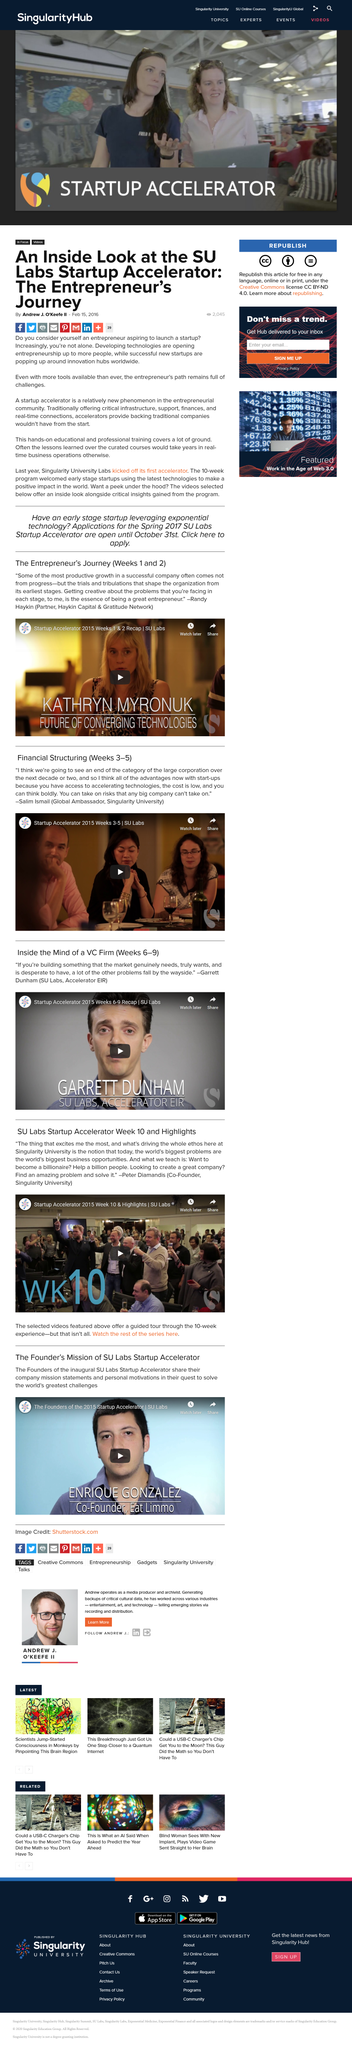Specify some key components in this picture. The term "Startup accelerator" refers to a new and innovative training tool that provides hands-on support and guidance to entrepreneurs. The article was written on February 15th, 2016. The entrepreneur's path is full of challenges. 